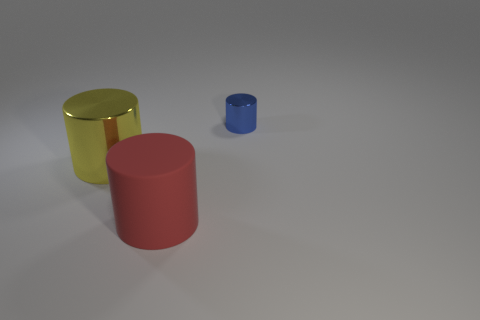Subtract all large cylinders. How many cylinders are left? 1 Add 2 green rubber cylinders. How many objects exist? 5 Subtract 0 brown balls. How many objects are left? 3 Subtract all large yellow shiny things. Subtract all metal objects. How many objects are left? 0 Add 1 large yellow metallic cylinders. How many large yellow metallic cylinders are left? 2 Add 3 small yellow metallic spheres. How many small yellow metallic spheres exist? 3 